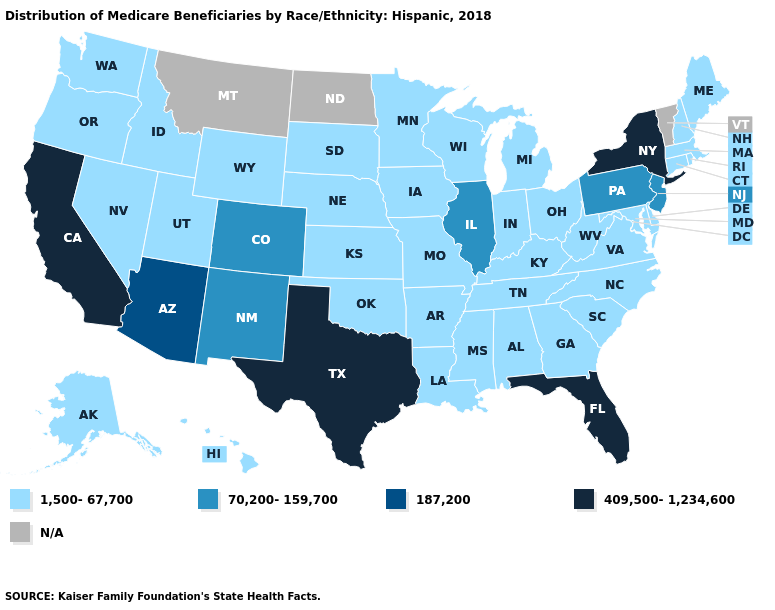Among the states that border Massachusetts , which have the lowest value?
Write a very short answer. Connecticut, New Hampshire, Rhode Island. Does the first symbol in the legend represent the smallest category?
Answer briefly. Yes. Does New York have the lowest value in the USA?
Answer briefly. No. Name the states that have a value in the range 1,500-67,700?
Quick response, please. Alabama, Alaska, Arkansas, Connecticut, Delaware, Georgia, Hawaii, Idaho, Indiana, Iowa, Kansas, Kentucky, Louisiana, Maine, Maryland, Massachusetts, Michigan, Minnesota, Mississippi, Missouri, Nebraska, Nevada, New Hampshire, North Carolina, Ohio, Oklahoma, Oregon, Rhode Island, South Carolina, South Dakota, Tennessee, Utah, Virginia, Washington, West Virginia, Wisconsin, Wyoming. Does the map have missing data?
Keep it brief. Yes. What is the lowest value in states that border South Carolina?
Be succinct. 1,500-67,700. Does California have the highest value in the USA?
Answer briefly. Yes. What is the value of Montana?
Concise answer only. N/A. Name the states that have a value in the range 409,500-1,234,600?
Be succinct. California, Florida, New York, Texas. What is the value of Michigan?
Be succinct. 1,500-67,700. What is the value of Ohio?
Give a very brief answer. 1,500-67,700. Name the states that have a value in the range N/A?
Quick response, please. Montana, North Dakota, Vermont. Name the states that have a value in the range 187,200?
Concise answer only. Arizona. Name the states that have a value in the range 1,500-67,700?
Give a very brief answer. Alabama, Alaska, Arkansas, Connecticut, Delaware, Georgia, Hawaii, Idaho, Indiana, Iowa, Kansas, Kentucky, Louisiana, Maine, Maryland, Massachusetts, Michigan, Minnesota, Mississippi, Missouri, Nebraska, Nevada, New Hampshire, North Carolina, Ohio, Oklahoma, Oregon, Rhode Island, South Carolina, South Dakota, Tennessee, Utah, Virginia, Washington, West Virginia, Wisconsin, Wyoming. 